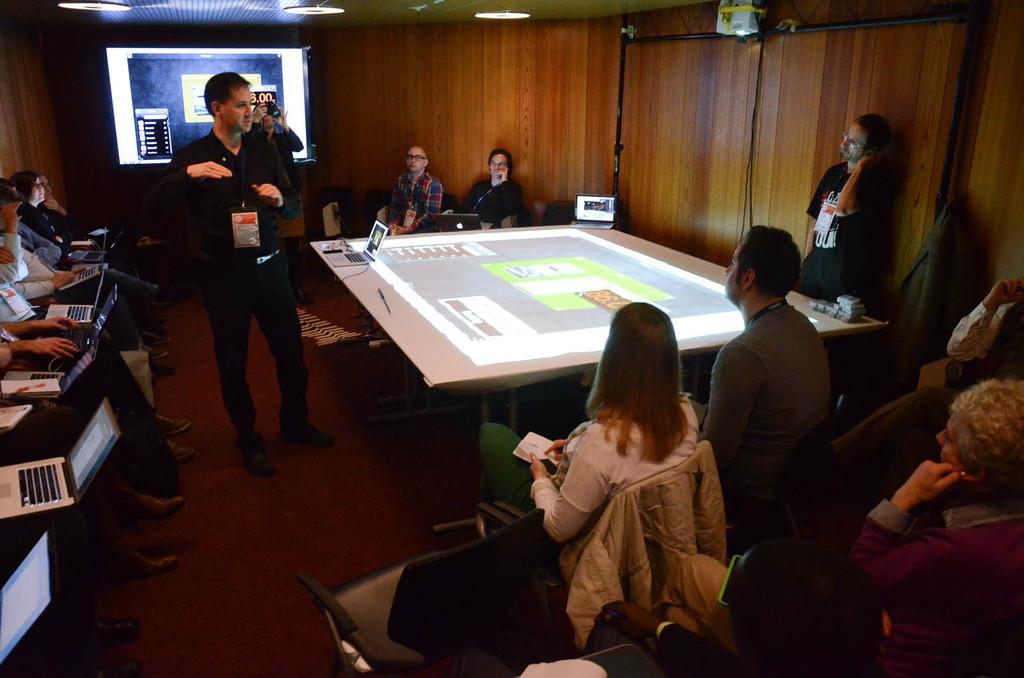Describe this image in one or two sentences. In the picture we can see few people sitting on the chairs with a laptops working on it and one person standing and explaining something to them and in the background we can see two people sitting on the chair and listening to him, beside them there is a screen which is hanged to the wall and to the ceiling there are lights. 